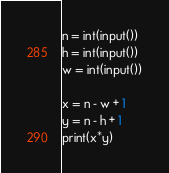<code> <loc_0><loc_0><loc_500><loc_500><_Python_>n = int(input())
h = int(input())
w = int(input())

x = n - w + 1
y = n - h + 1
print(x*y)
</code> 